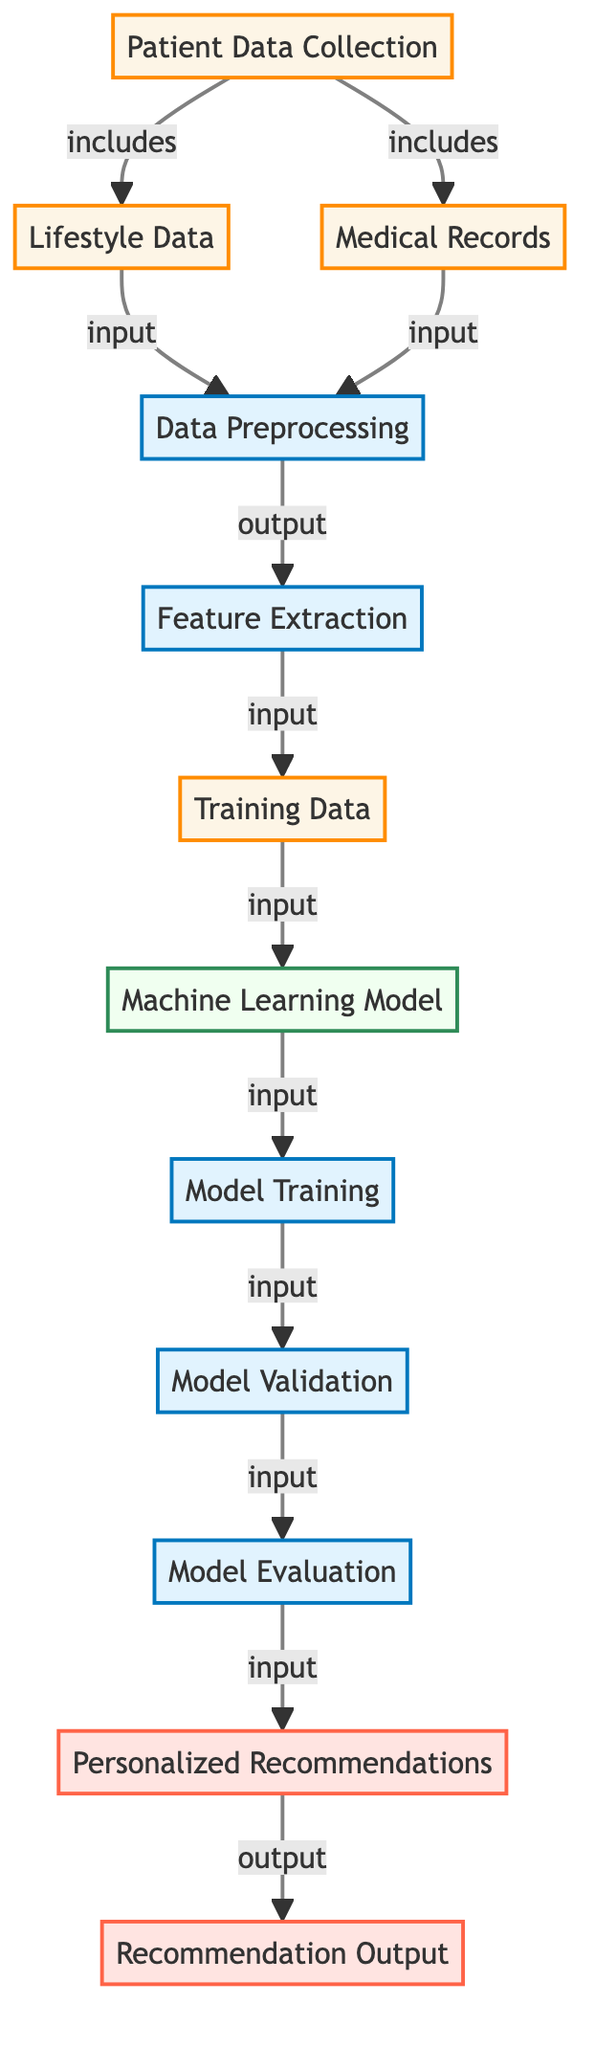What is the first step in the diagram? The diagram begins with the "Patient Data Collection" node, indicating this is the initial step in the process.
Answer: Patient Data Collection How many data sources are included in the "Patient Data Collection"? The "Patient Data Collection" node includes two data sources: "Lifestyle Data" and "Medical Records." Therefore, there are two sources.
Answer: 2 What type of data transformation is done after collecting patient data? After collecting lifestyle and medical records, the diagram indicates that the next step is "Data Preprocessing," which involves transforming the collected data.
Answer: Data Preprocessing Which node is directly responsible for generating personalized recommendations? The "Personalized Recommendations" node is the step in the diagram that is directly responsible for generating recommendations based on the processed data.
Answer: Personalized Recommendations What type of model is used before the model training step? The machine learning framework represented in the diagram is indicated by the "Machine Learning Model" node, which is utilized before the training process.
Answer: Machine Learning Model How many total output nodes are present in the diagram? The output section of the diagram shows two nodes: "Personalized Recommendations" and "Recommendation Output," totaling two output nodes.
Answer: 2 Which step directly follows "Model Validation"? After "Model Validation," the next step indicated in the diagram is "Model Evaluation," which assesses the model's performance based on validation results.
Answer: Model Evaluation What is the relationship between "Feature Extraction" and "Training Data"? The diagram shows that "Feature Extraction" outputs the "Training Data," meaning that feature extraction is crucial for preparing data used in model training.
Answer: Feature Extraction Which process follows directly from "Model Evaluation"? After "Model Evaluation," the next step in the flowchart is "Personalized Recommendations," indicating it utilizes the outcomes of the evaluation process.
Answer: Personalized Recommendations 